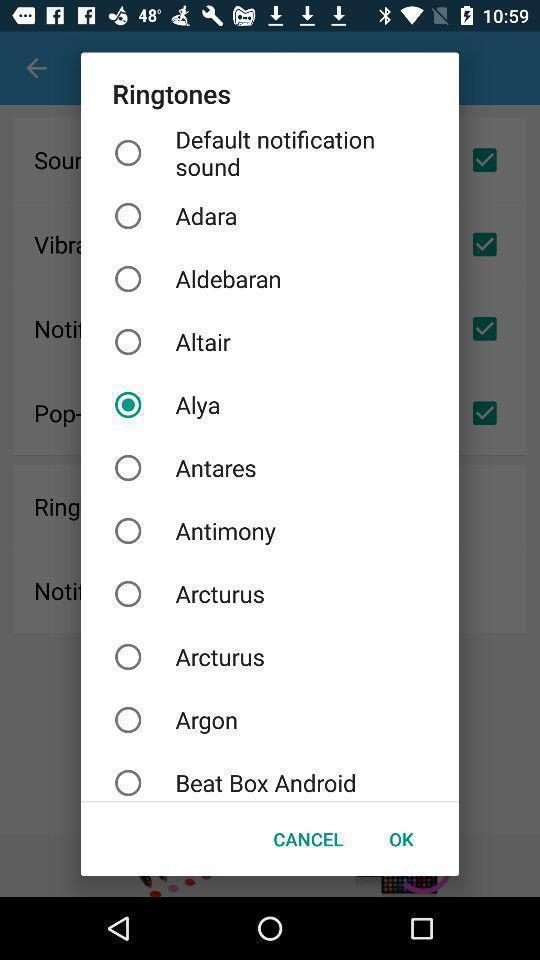Describe the content in this image. Screen displaying list of various ringtones. 